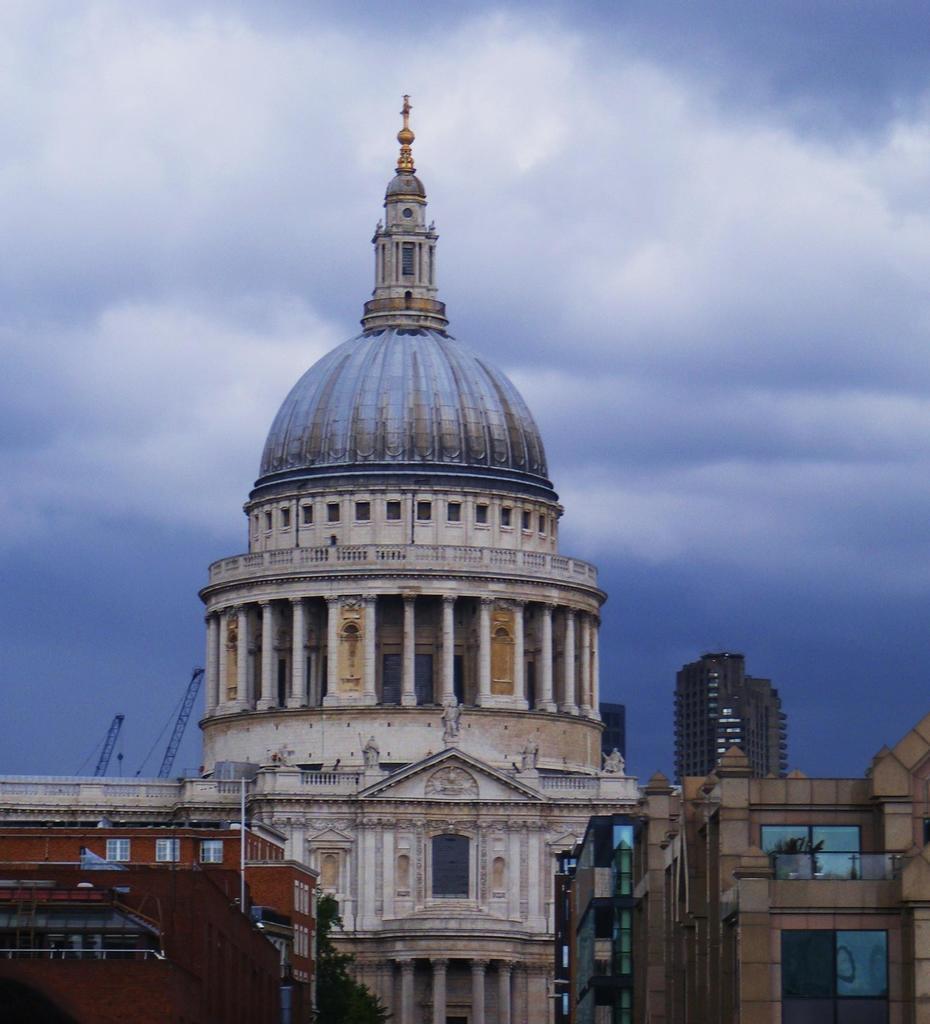How would you summarize this image in a sentence or two? In this picture we can see buildings, there is a tree at the bottom, we can see the sky at the top of the picture. 